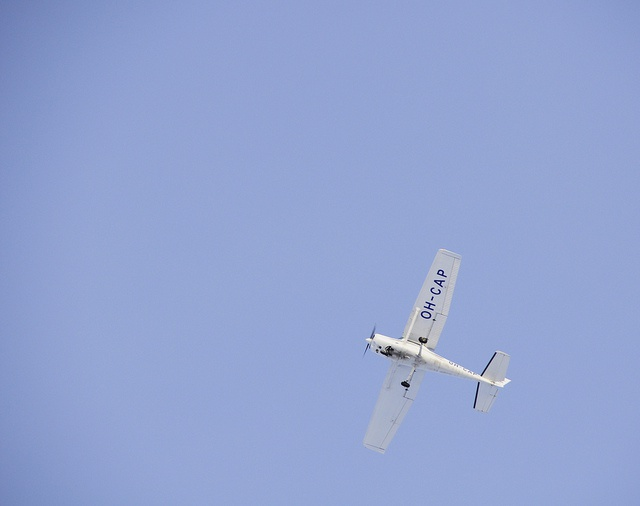Describe the objects in this image and their specific colors. I can see a airplane in gray, darkgray, and lightgray tones in this image. 